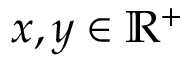<formula> <loc_0><loc_0><loc_500><loc_500>x , y \in \mathbb { R } ^ { + }</formula> 